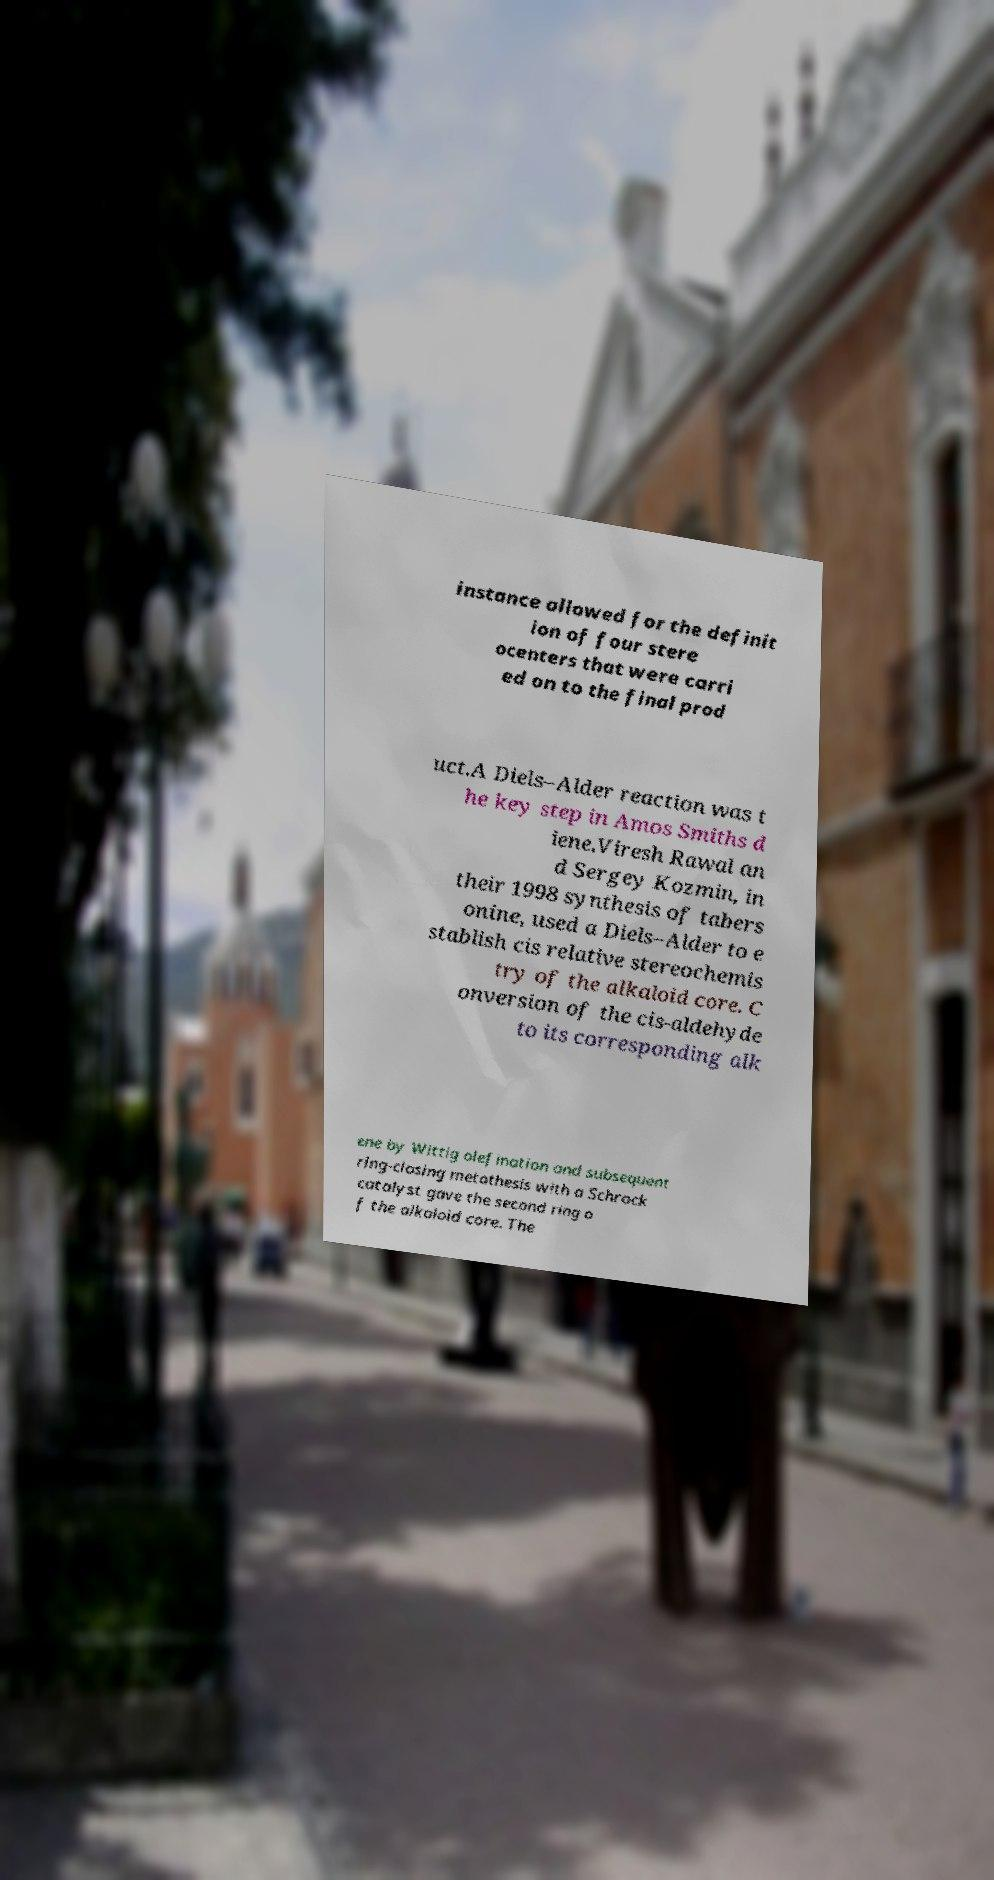Please identify and transcribe the text found in this image. instance allowed for the definit ion of four stere ocenters that were carri ed on to the final prod uct.A Diels–Alder reaction was t he key step in Amos Smiths d iene.Viresh Rawal an d Sergey Kozmin, in their 1998 synthesis of tabers onine, used a Diels–Alder to e stablish cis relative stereochemis try of the alkaloid core. C onversion of the cis-aldehyde to its corresponding alk ene by Wittig olefination and subsequent ring-closing metathesis with a Schrock catalyst gave the second ring o f the alkaloid core. The 